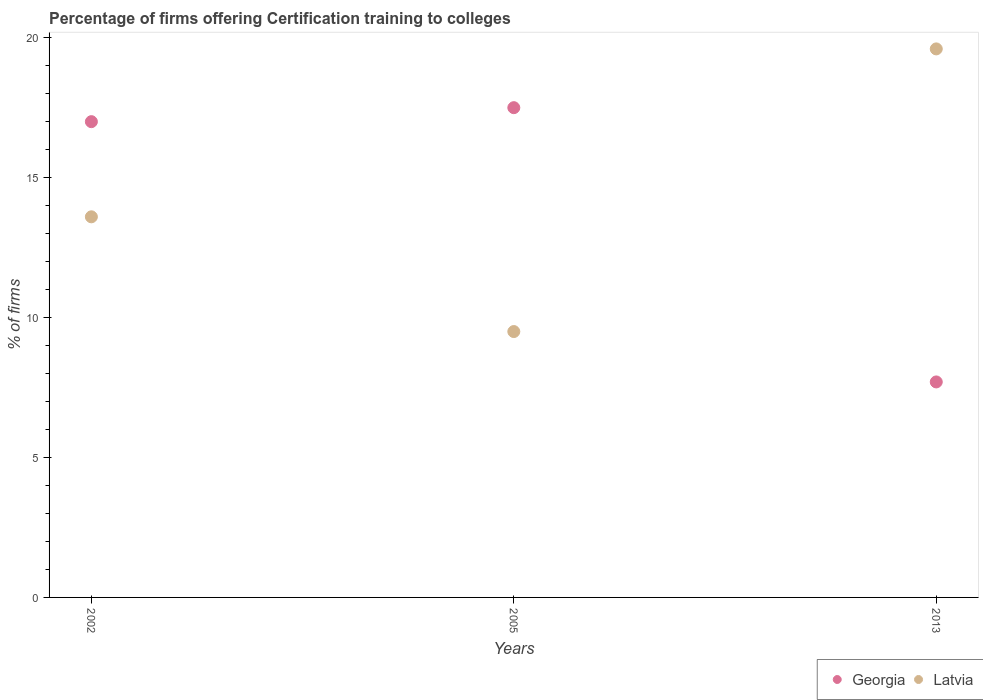Is the number of dotlines equal to the number of legend labels?
Your response must be concise. Yes. Across all years, what is the minimum percentage of firms offering certification training to colleges in Latvia?
Ensure brevity in your answer.  9.5. In which year was the percentage of firms offering certification training to colleges in Georgia minimum?
Offer a very short reply. 2013. What is the total percentage of firms offering certification training to colleges in Latvia in the graph?
Ensure brevity in your answer.  42.7. What is the difference between the percentage of firms offering certification training to colleges in Georgia in 2005 and that in 2013?
Your answer should be very brief. 9.8. What is the difference between the percentage of firms offering certification training to colleges in Latvia in 2013 and the percentage of firms offering certification training to colleges in Georgia in 2005?
Ensure brevity in your answer.  2.1. What is the average percentage of firms offering certification training to colleges in Georgia per year?
Provide a short and direct response. 14.07. What is the ratio of the percentage of firms offering certification training to colleges in Latvia in 2002 to that in 2005?
Your response must be concise. 1.43. What is the difference between the highest and the lowest percentage of firms offering certification training to colleges in Latvia?
Your response must be concise. 10.1. Does the percentage of firms offering certification training to colleges in Latvia monotonically increase over the years?
Provide a short and direct response. No. Is the percentage of firms offering certification training to colleges in Latvia strictly less than the percentage of firms offering certification training to colleges in Georgia over the years?
Your response must be concise. No. How many dotlines are there?
Make the answer very short. 2. Are the values on the major ticks of Y-axis written in scientific E-notation?
Your response must be concise. No. Where does the legend appear in the graph?
Your answer should be very brief. Bottom right. How are the legend labels stacked?
Offer a terse response. Horizontal. What is the title of the graph?
Your answer should be very brief. Percentage of firms offering Certification training to colleges. What is the label or title of the Y-axis?
Offer a very short reply. % of firms. What is the % of firms in Latvia in 2005?
Provide a short and direct response. 9.5. What is the % of firms in Latvia in 2013?
Make the answer very short. 19.6. Across all years, what is the maximum % of firms of Georgia?
Provide a short and direct response. 17.5. Across all years, what is the maximum % of firms in Latvia?
Your answer should be compact. 19.6. Across all years, what is the minimum % of firms of Latvia?
Your answer should be compact. 9.5. What is the total % of firms in Georgia in the graph?
Your answer should be compact. 42.2. What is the total % of firms of Latvia in the graph?
Provide a short and direct response. 42.7. What is the difference between the % of firms in Georgia in 2002 and that in 2005?
Provide a succinct answer. -0.5. What is the difference between the % of firms of Latvia in 2002 and that in 2005?
Your answer should be compact. 4.1. What is the difference between the % of firms in Georgia in 2005 and that in 2013?
Keep it short and to the point. 9.8. What is the difference between the % of firms in Latvia in 2005 and that in 2013?
Ensure brevity in your answer.  -10.1. What is the difference between the % of firms in Georgia in 2002 and the % of firms in Latvia in 2005?
Keep it short and to the point. 7.5. What is the difference between the % of firms of Georgia in 2002 and the % of firms of Latvia in 2013?
Your answer should be very brief. -2.6. What is the difference between the % of firms of Georgia in 2005 and the % of firms of Latvia in 2013?
Your response must be concise. -2.1. What is the average % of firms of Georgia per year?
Offer a terse response. 14.07. What is the average % of firms of Latvia per year?
Your answer should be very brief. 14.23. What is the ratio of the % of firms in Georgia in 2002 to that in 2005?
Make the answer very short. 0.97. What is the ratio of the % of firms of Latvia in 2002 to that in 2005?
Offer a very short reply. 1.43. What is the ratio of the % of firms in Georgia in 2002 to that in 2013?
Provide a short and direct response. 2.21. What is the ratio of the % of firms of Latvia in 2002 to that in 2013?
Keep it short and to the point. 0.69. What is the ratio of the % of firms in Georgia in 2005 to that in 2013?
Offer a terse response. 2.27. What is the ratio of the % of firms of Latvia in 2005 to that in 2013?
Your answer should be compact. 0.48. What is the difference between the highest and the second highest % of firms of Latvia?
Provide a succinct answer. 6. 